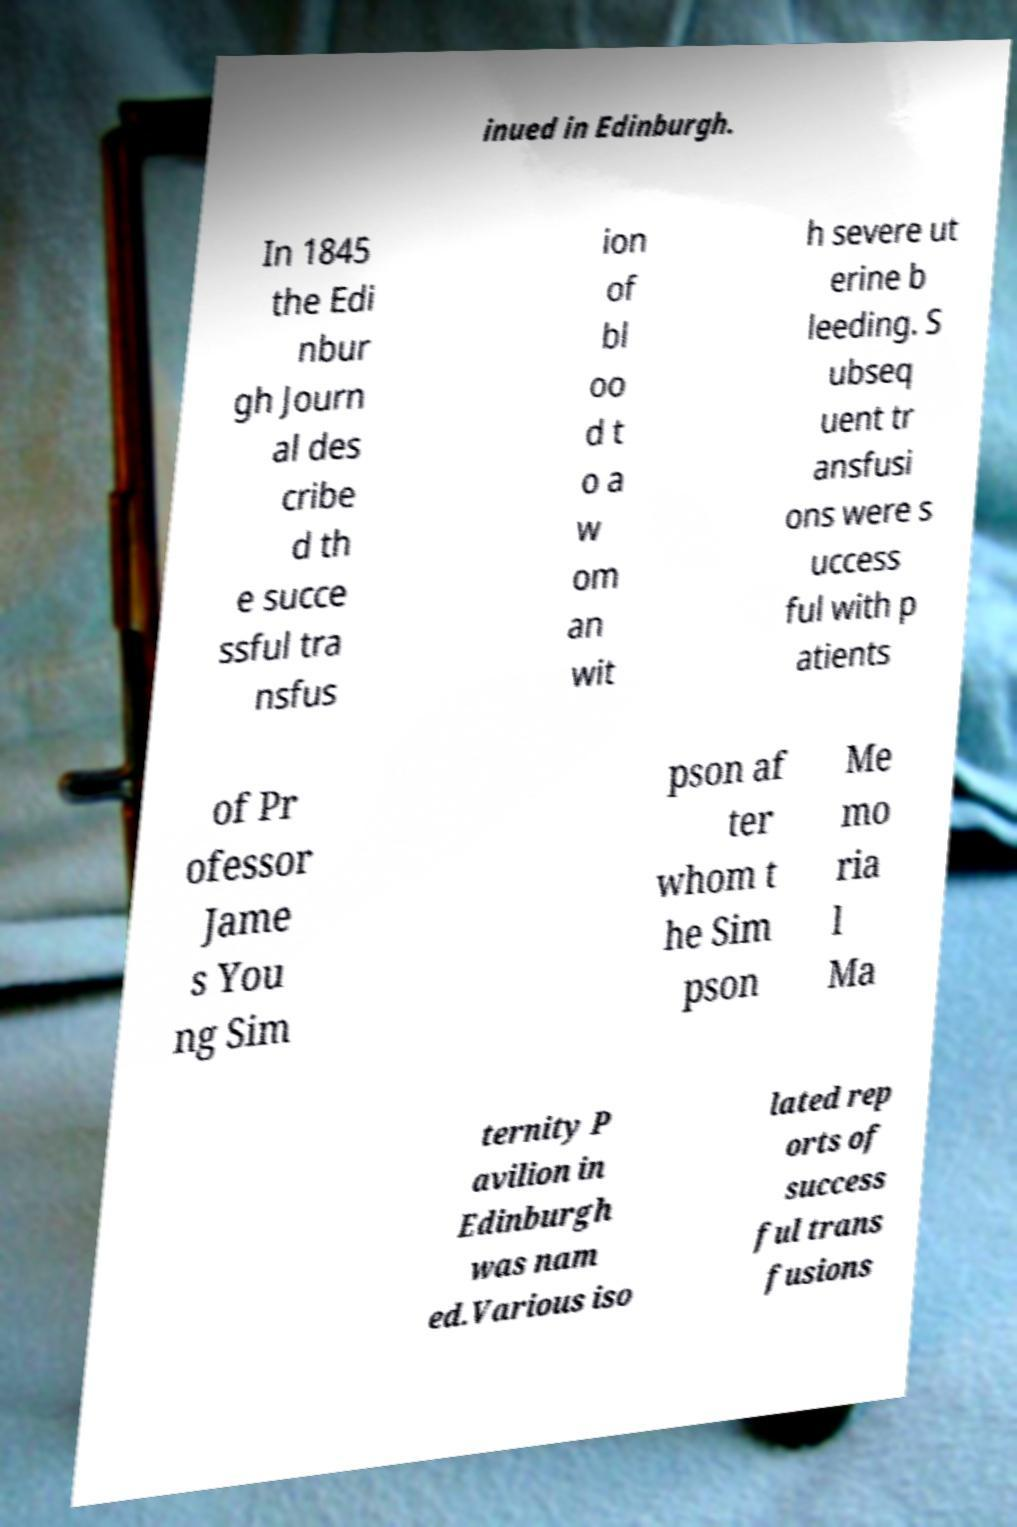Please identify and transcribe the text found in this image. inued in Edinburgh. In 1845 the Edi nbur gh Journ al des cribe d th e succe ssful tra nsfus ion of bl oo d t o a w om an wit h severe ut erine b leeding. S ubseq uent tr ansfusi ons were s uccess ful with p atients of Pr ofessor Jame s You ng Sim pson af ter whom t he Sim pson Me mo ria l Ma ternity P avilion in Edinburgh was nam ed.Various iso lated rep orts of success ful trans fusions 